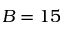<formula> <loc_0><loc_0><loc_500><loc_500>B = 1 5</formula> 